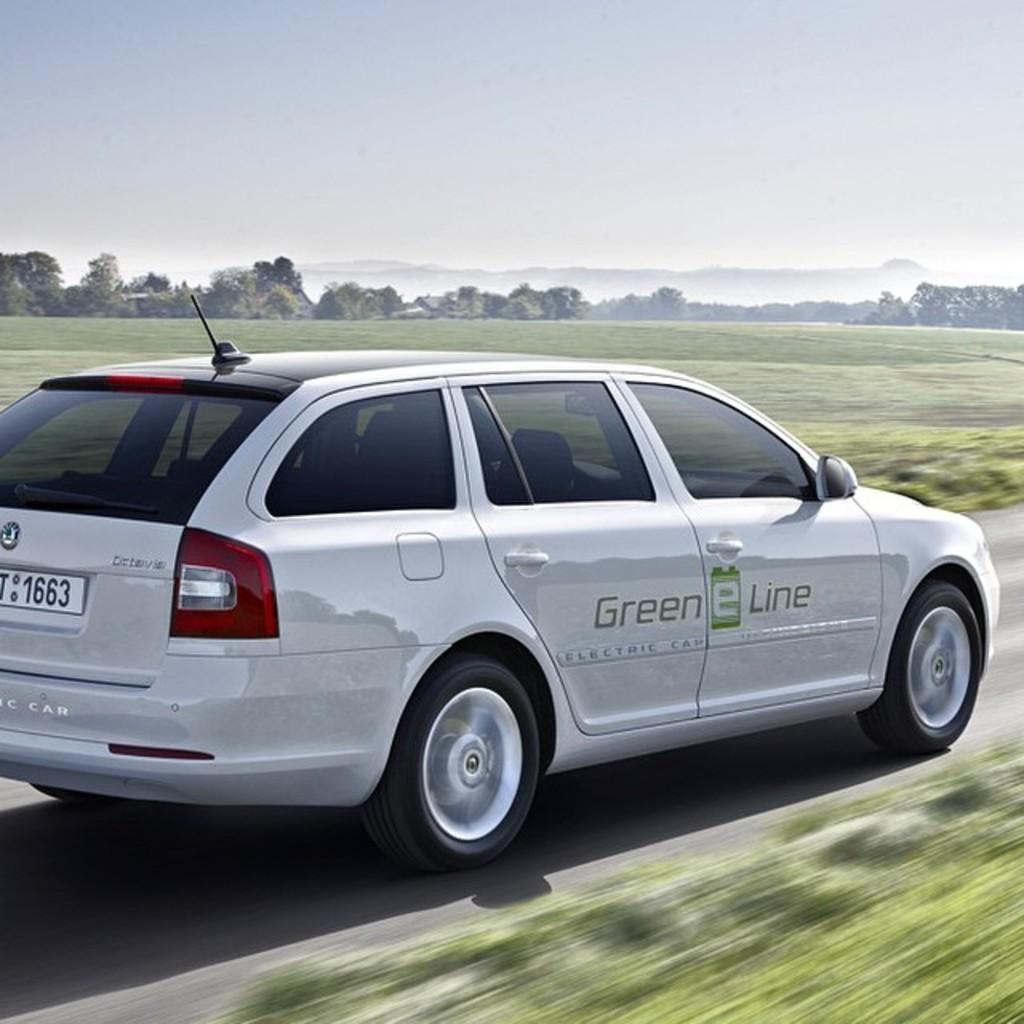What is the main subject of the image? The main subject of the image is a car on the road. What is the surface of the sides of the road? The sides of the road have a grass surface. What can be seen in the background of the image? There are trees and the sky visible in the background of the image. What is the condition of the sky in the image? Clouds are present in the sky. What type of honey is being collected by the bees in the image? There are no bees or honey present in the image; it features a car on the road with a grass surface, trees in the background, and a sky with clouds. 